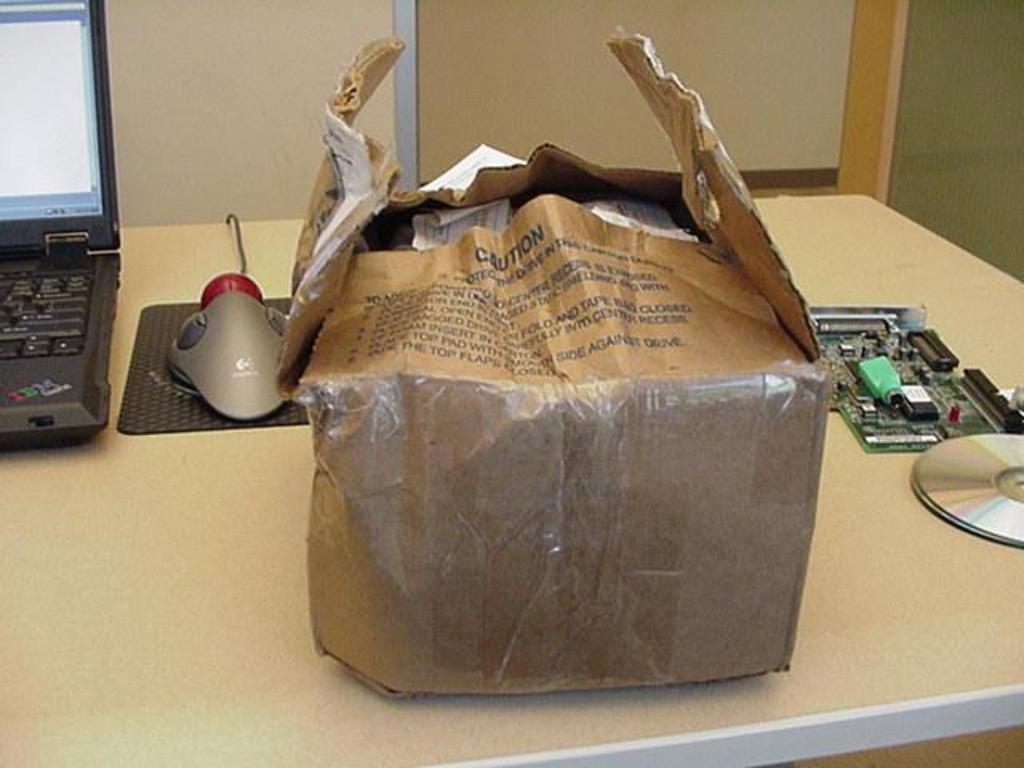What is placed on the table in the image? There is a cardboard box, a laptop, a mouse, a VGA card, and two CD ROMs on the table. Can you describe the laptop in the image? The laptop is on the table. What other electronic device is present on the table? There is a mouse on the table. How many CD ROMs are on the table? There are two CD ROMs on the table. What type of locket is hanging around the laptop's neck in the image? There is no locket present in the image; it features a cardboard box, laptop, mouse, VGA card, and CD ROMs on a table. 